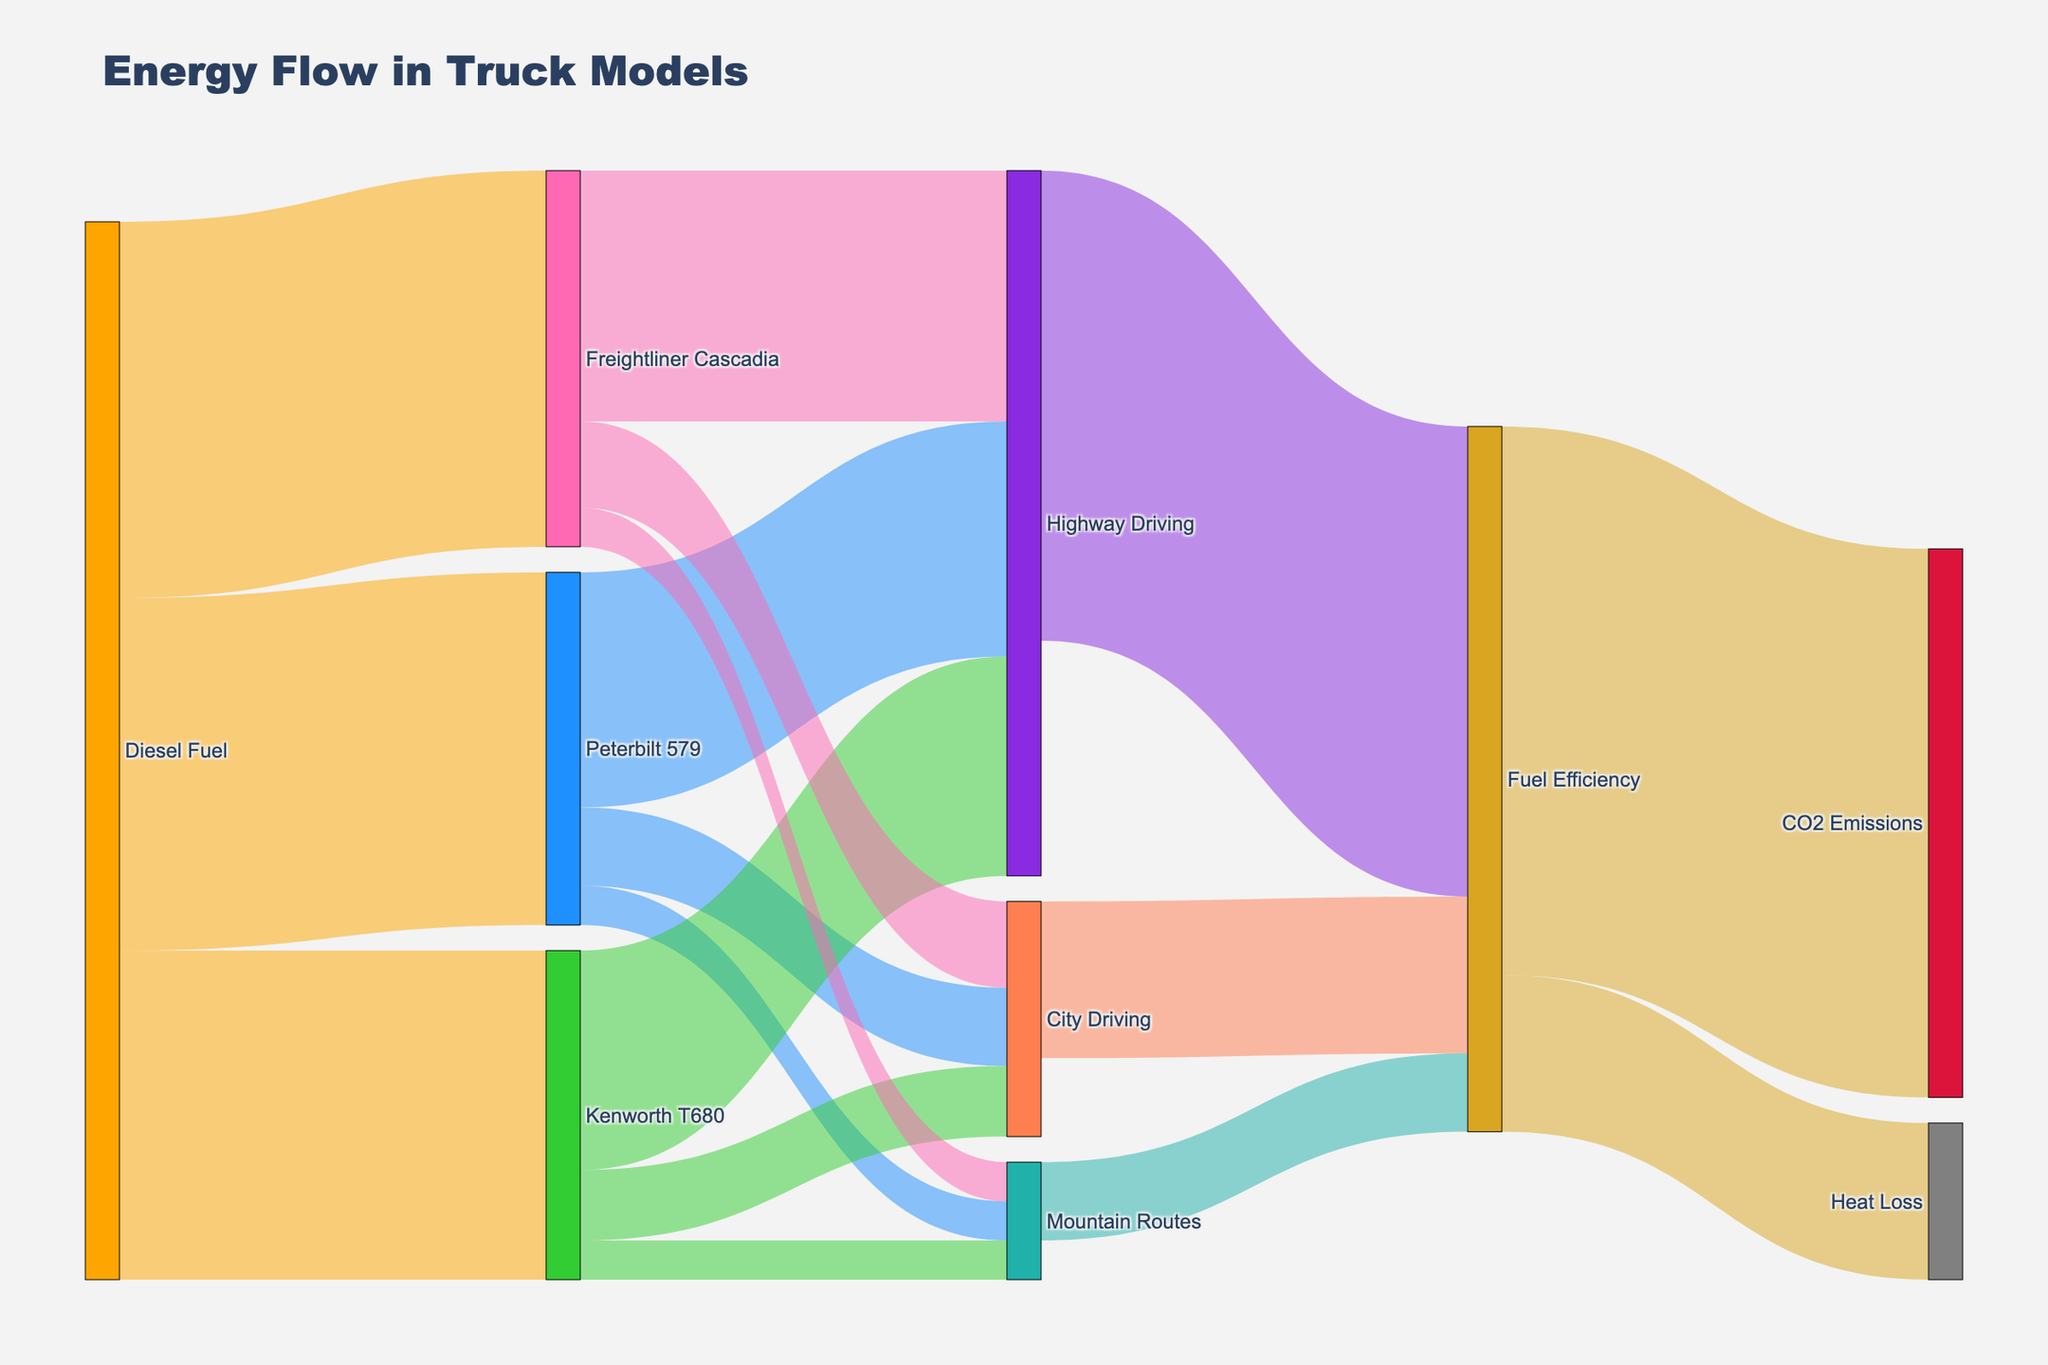What's the title of the Sankey diagram? The title can be found at the top of the diagram.
Answer: Energy Flow in Truck Models What are the three truck models shown in the diagram? The truck models are labeled after the "Diesel Fuel" source node in the diagram. They are Peterbilt 579, Kenworth T680, and Freightliner Cascadia.
Answer: Peterbilt 579, Kenworth T680, Freightliner Cascadia Which truck model consumes the most diesel fuel? Compare the values from the "Diesel Fuel" source node to each truck model's node. Freightliner Cascadia has the highest value of 480.
Answer: Freightliner Cascadia How much diesel fuel does Kenworth T680 consume? Check the value labeled between "Diesel Fuel" and "Kenworth T680".
Answer: 420 What is the total amount of diesel fuel used for city driving? Sum the values of city driving for all truck models: Peterbilt 579 (100), Kenworth T680 (90), Freightliner Cascadia (110). 100 + 90 + 110 = 300
Answer: 300 Which truck performs the best in highway driving in terms of diesel fuel efficiency? Compare the values of "Highway Driving" for each truck model. Freightliner Cascadia has the highest value of 320.
Answer: Freightliner Cascadia What is the total amount of diesel fuel used in mountain routes across all truck models? Sum the values of mountain routes for all truck models: Peterbilt 579 (50), Kenworth T680 (50), Freightliner Cascadia (50). 50 + 50 + 50 = 150
Answer: 150 Which driving condition has the highest fuel efficiency? Check the values associated with "Fuel Efficiency". Highway Driving has 600, City Driving has 200, Mountain Routes have 100. Hence, Highway Driving has the highest value.
Answer: Highway Driving What proportion of the fuel efficiency leads to CO2 emissions? The sum of all fuel efficiency values is 1000 (700 from CO2 Emissions and 200 from Heat Loss). The proportion for CO2 emissions is 700/1000 = 0.7 or 70%.
Answer: 70% How do CO2 emissions compare to heat loss in terms of values? Compare the values from the "Fuel Efficiency" link to CO2 Emissions and Heat Loss. CO2 Emissions is 700, Heat Loss is 200. CO2 Emissions (700) is significantly larger than Heat Loss (200).
Answer: CO2 Emissions is larger 